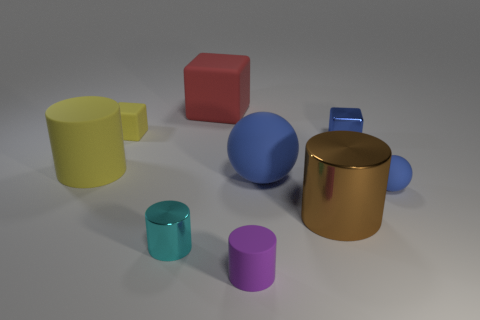There is a tiny object that is behind the blue metal thing; is its color the same as the large matte cylinder?
Offer a very short reply. Yes. There is a block that is the same color as the large matte sphere; what material is it?
Keep it short and to the point. Metal. There is another sphere that is the same color as the small sphere; what size is it?
Ensure brevity in your answer.  Large. Are there any shiny cubes of the same color as the small ball?
Your answer should be very brief. Yes. What number of things are either yellow cubes or matte things that are behind the small matte cylinder?
Make the answer very short. 5. The large object that is behind the tiny block that is to the left of the ball behind the small ball is what color?
Provide a short and direct response. Red. There is a cyan thing that is the same shape as the purple object; what material is it?
Keep it short and to the point. Metal. What color is the tiny metallic cylinder?
Offer a terse response. Cyan. Is the color of the large matte cylinder the same as the tiny rubber cylinder?
Ensure brevity in your answer.  No. What number of rubber objects are small cylinders or tiny spheres?
Make the answer very short. 2. 